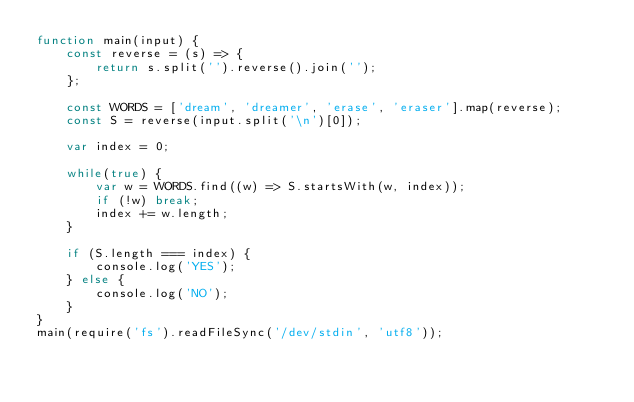Convert code to text. <code><loc_0><loc_0><loc_500><loc_500><_JavaScript_>function main(input) {
    const reverse = (s) => {
        return s.split('').reverse().join('');
    };

    const WORDS = ['dream', 'dreamer', 'erase', 'eraser'].map(reverse);
    const S = reverse(input.split('\n')[0]);

    var index = 0;

    while(true) {
        var w = WORDS.find((w) => S.startsWith(w, index));
        if (!w) break;
        index += w.length;
    }

    if (S.length === index) {
        console.log('YES');
    } else {
        console.log('NO');
    }
}
main(require('fs').readFileSync('/dev/stdin', 'utf8'));</code> 